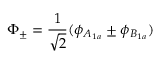Convert formula to latex. <formula><loc_0><loc_0><loc_500><loc_500>\Phi _ { \pm } = \frac { 1 } { \sqrt { 2 } } ( \phi _ { A _ { 1 a } } \pm \phi _ { B _ { 1 a } } )</formula> 